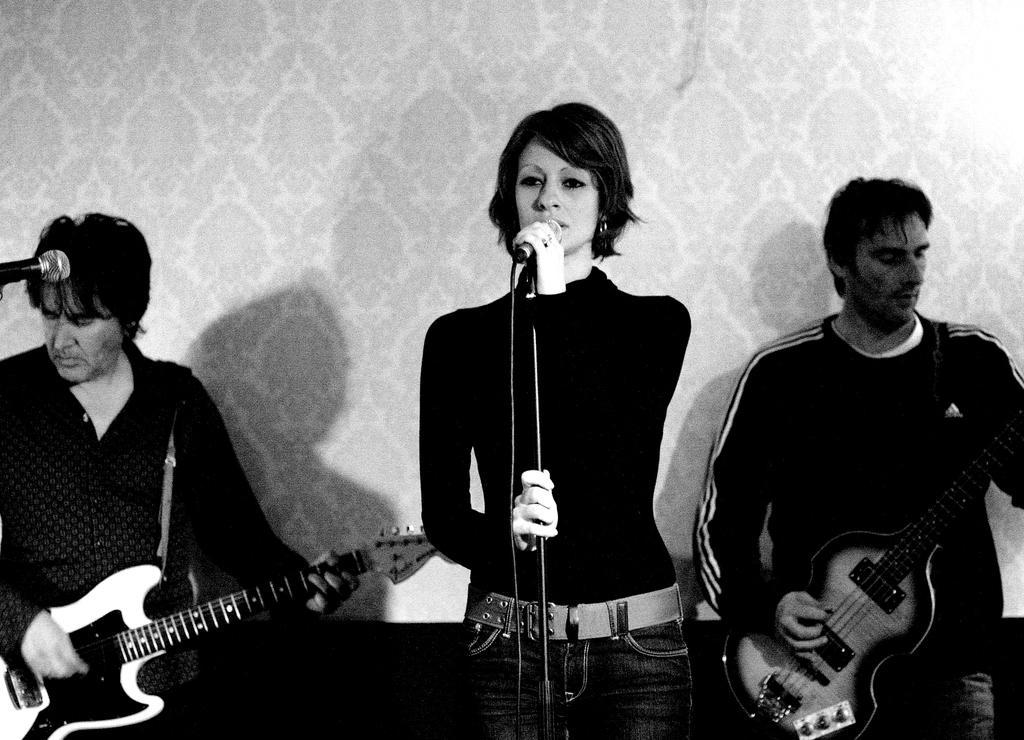Please provide a concise description of this image. This is a black and white image. This looks like a musical concert. There are three people in this image, the one who is in the middle is woman ,two people on left side and right side are men. Both men are playing guitar and this girl is singing song. 